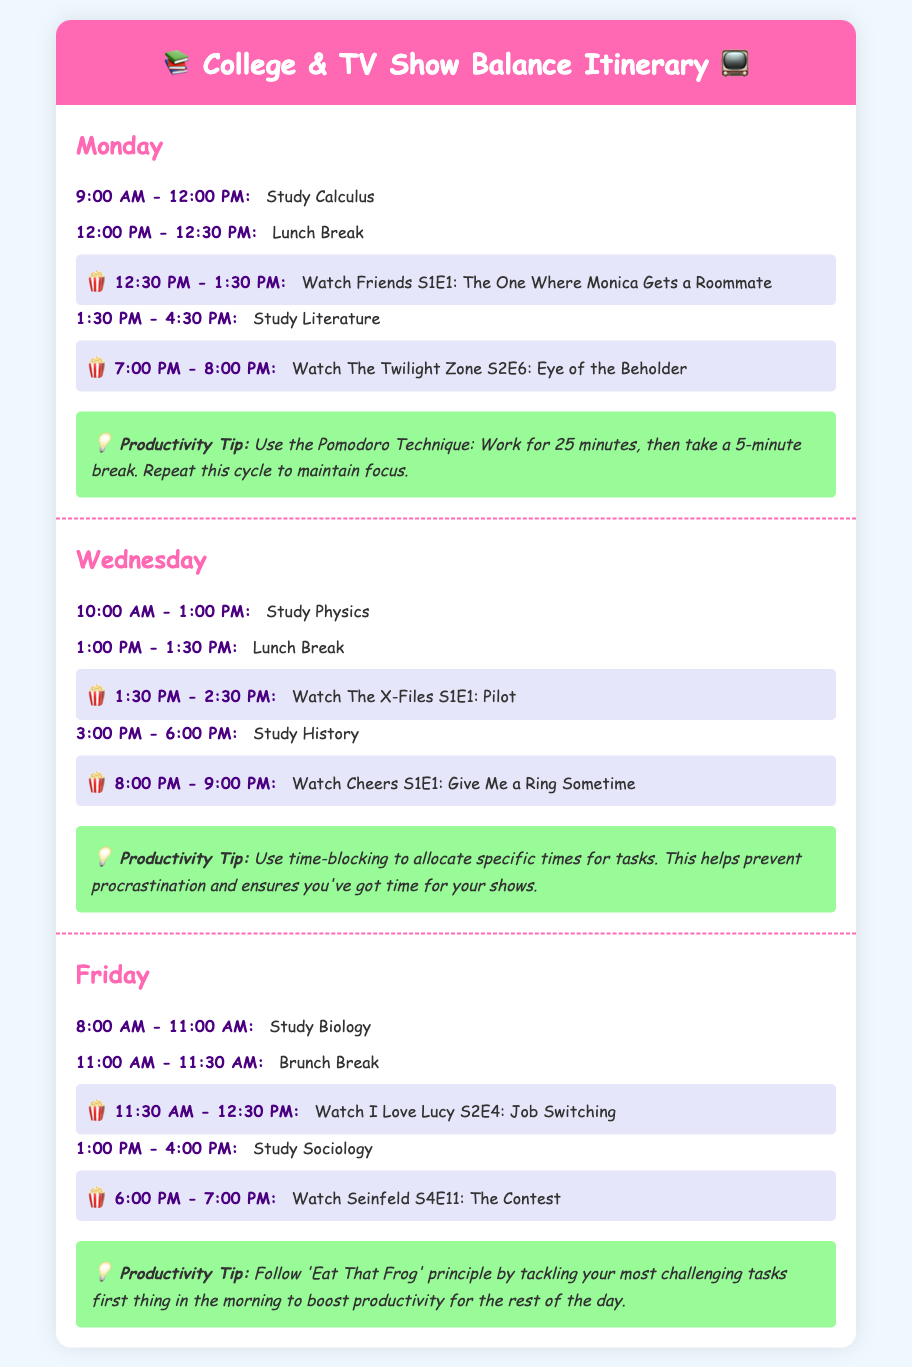What show is watched on Monday at 12:30 PM? The document lists the TV show watched at this time as Friends S1E1: The One Where Monica Gets a Roommate.
Answer: Friends S1E1: The One Where Monica Gets a Roommate How long is the study session for Physics on Wednesday? The schedule indicates the study session lasts from 10:00 AM to 1:00 PM, which is a total of 3 hours.
Answer: 3 hours What productivity tip is mentioned for Monday? According to the itinerary, the productivity tip for Monday is to use the Pomodoro Technique.
Answer: Use the Pomodoro Technique At what time does the brunch break occur on Friday? The itinerary specifies that the brunch break occurs from 11:00 AM to 11:30 AM.
Answer: 11:00 AM - 11:30 AM How many episodes of TV shows are scheduled on days where study occurs? The document outlines two TV episodes each on Monday, Wednesday, and Friday, giving a total of 6 episodes.
Answer: 6 episodes What is the first activity listed for Friday? The first activity in the Friday schedule is to study Biology from 8:00 AM to 11:00 AM.
Answer: Study Biology Which day's study sessions include a lunch break? The itinerary shows that both Monday and Wednesday include a lunch break after morning study sessions.
Answer: Monday and Wednesday What time does the first TV show start on the itinerary? The first TV show on the itinerary starts at 12:30 PM on Monday.
Answer: 12:30 PM 